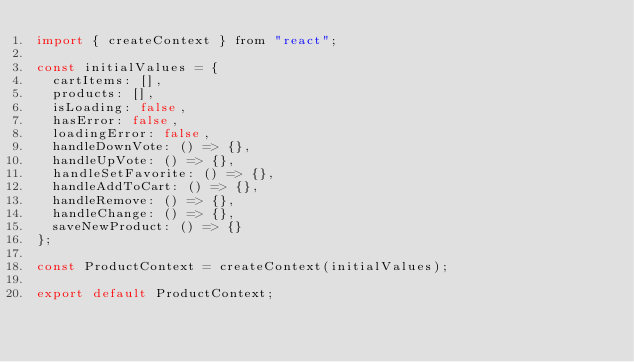Convert code to text. <code><loc_0><loc_0><loc_500><loc_500><_JavaScript_>import { createContext } from "react";

const initialValues = {
  cartItems: [],
  products: [],
  isLoading: false,
  hasError: false,
  loadingError: false,
  handleDownVote: () => {},
  handleUpVote: () => {},
  handleSetFavorite: () => {},
  handleAddToCart: () => {},
  handleRemove: () => {},
  handleChange: () => {},
  saveNewProduct: () => {}
};

const ProductContext = createContext(initialValues);

export default ProductContext;</code> 